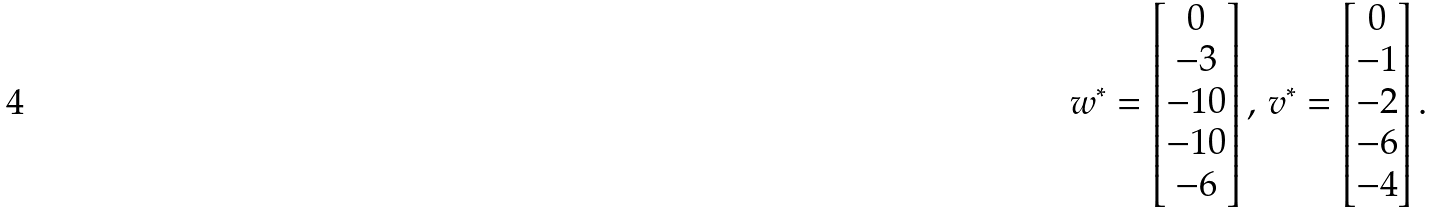Convert formula to latex. <formula><loc_0><loc_0><loc_500><loc_500>w ^ { \ast } = \begin{bmatrix} 0 \\ - 3 \\ - 1 0 \\ - 1 0 \\ - 6 \end{bmatrix} , \, v ^ { \ast } = \begin{bmatrix} 0 \\ - 1 \\ - 2 \\ - 6 \\ - 4 \end{bmatrix} .</formula> 